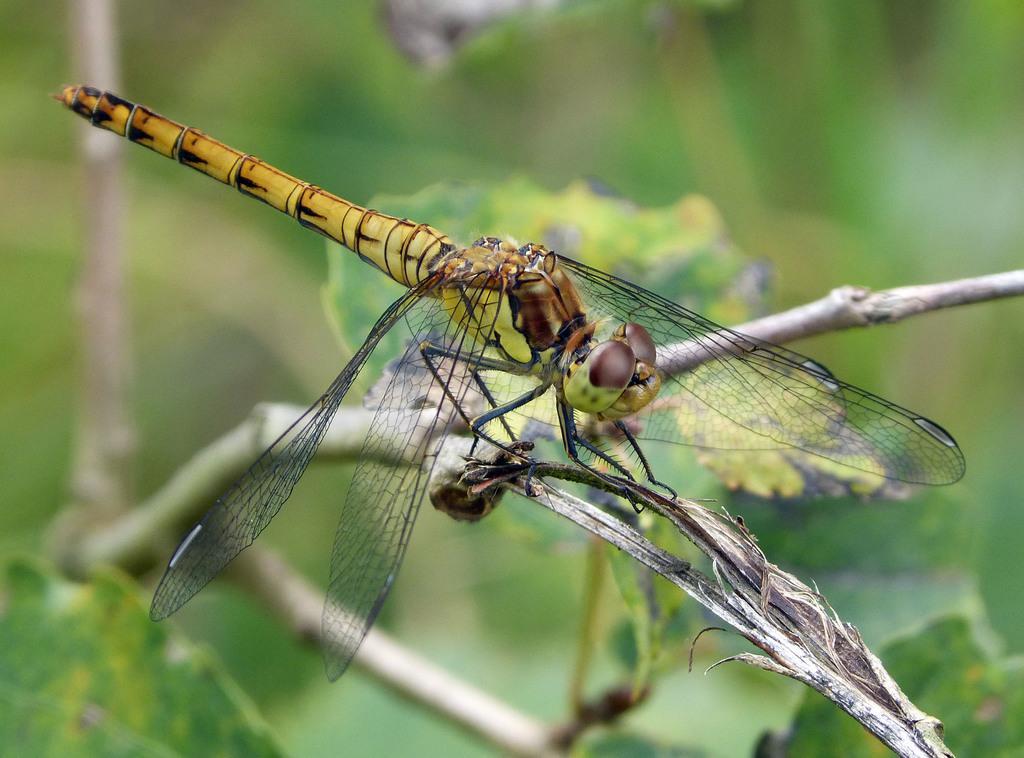Could you give a brief overview of what you see in this image? In this picture we can see an insect on a tree branch and in the background we can see leaves and it is blurry. 